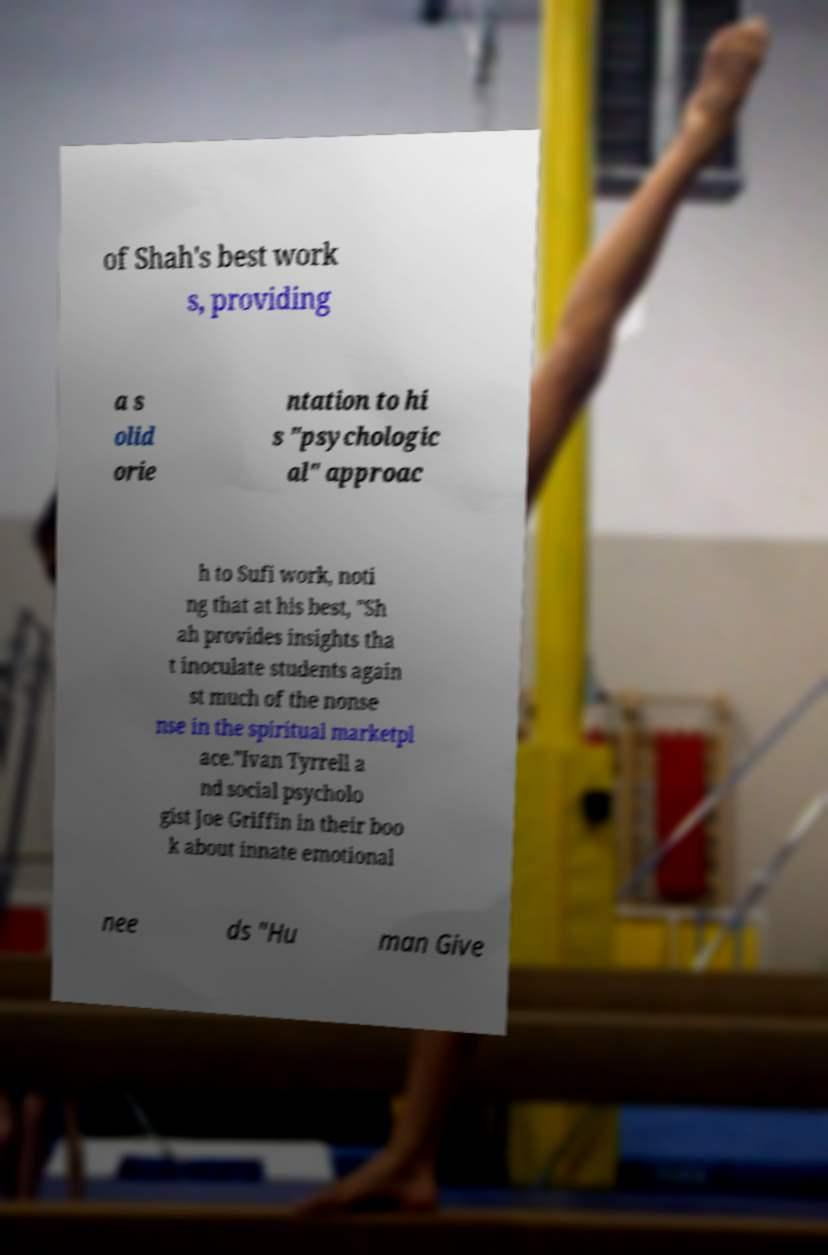What messages or text are displayed in this image? I need them in a readable, typed format. of Shah's best work s, providing a s olid orie ntation to hi s "psychologic al" approac h to Sufi work, noti ng that at his best, "Sh ah provides insights tha t inoculate students again st much of the nonse nse in the spiritual marketpl ace."Ivan Tyrrell a nd social psycholo gist Joe Griffin in their boo k about innate emotional nee ds "Hu man Give 